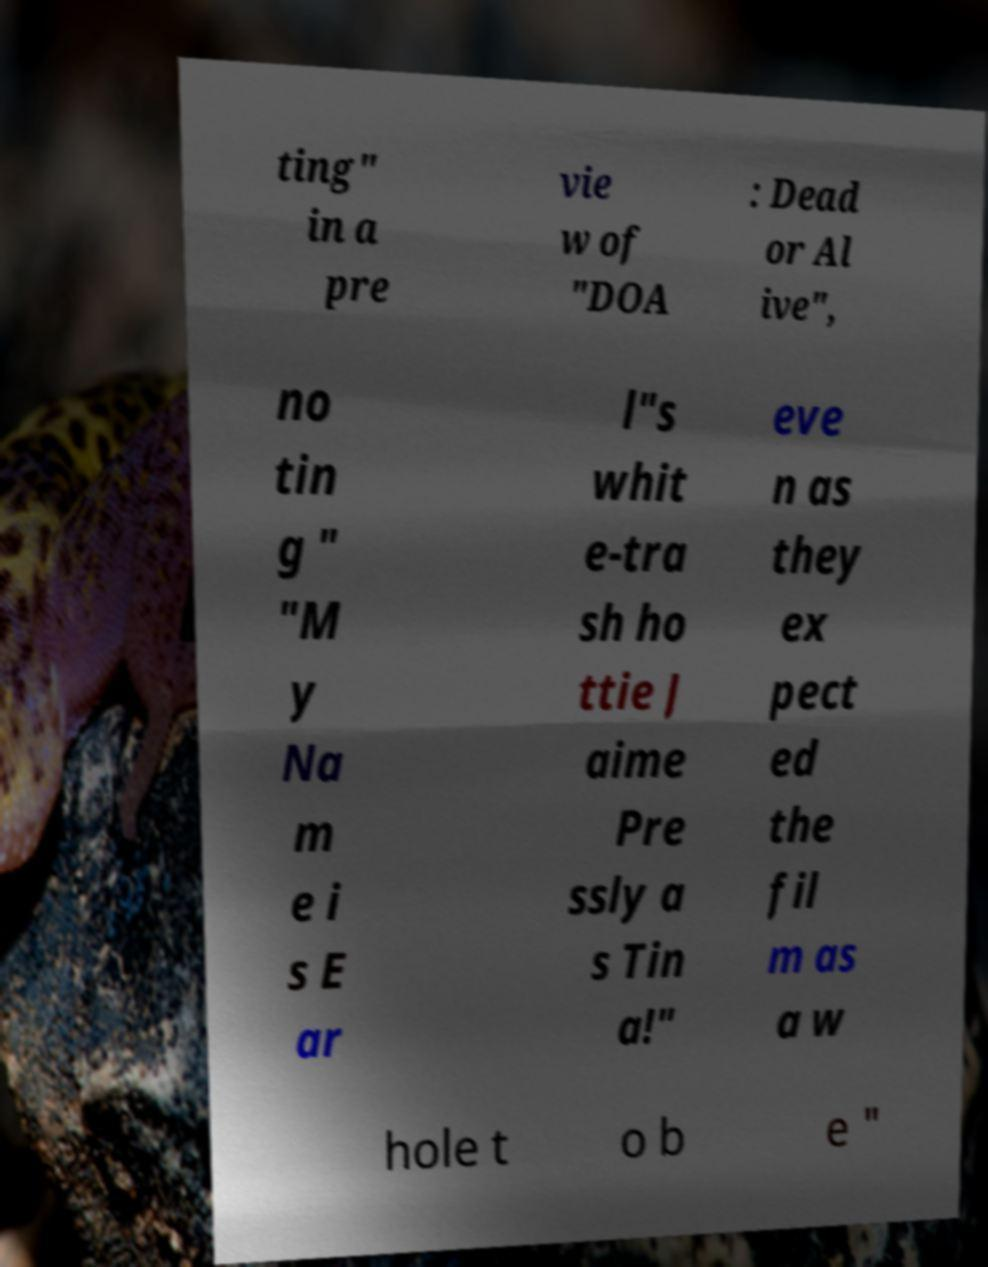I need the written content from this picture converted into text. Can you do that? ting" in a pre vie w of "DOA : Dead or Al ive", no tin g " "M y Na m e i s E ar l"s whit e-tra sh ho ttie J aime Pre ssly a s Tin a!" eve n as they ex pect ed the fil m as a w hole t o b e " 